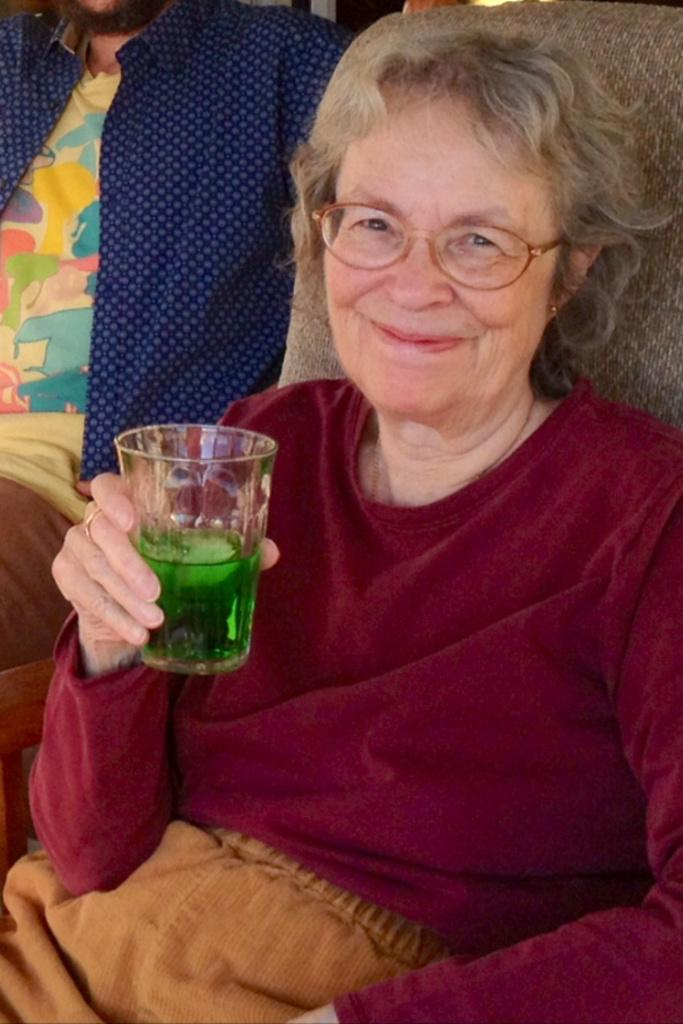Who is the main subject in the center of the image? There is a lady in the center of the image. What is the lady holding in her hand? The lady is holding a glass in her hand. Can you describe the man in the image? There is a man in the image, and he is wearing a blue color shirt. What advice does the farmer give to the lady in the image? There is no farmer present in the image, so no advice can be given. What type of oven is visible in the image? There is no oven present in the image. 